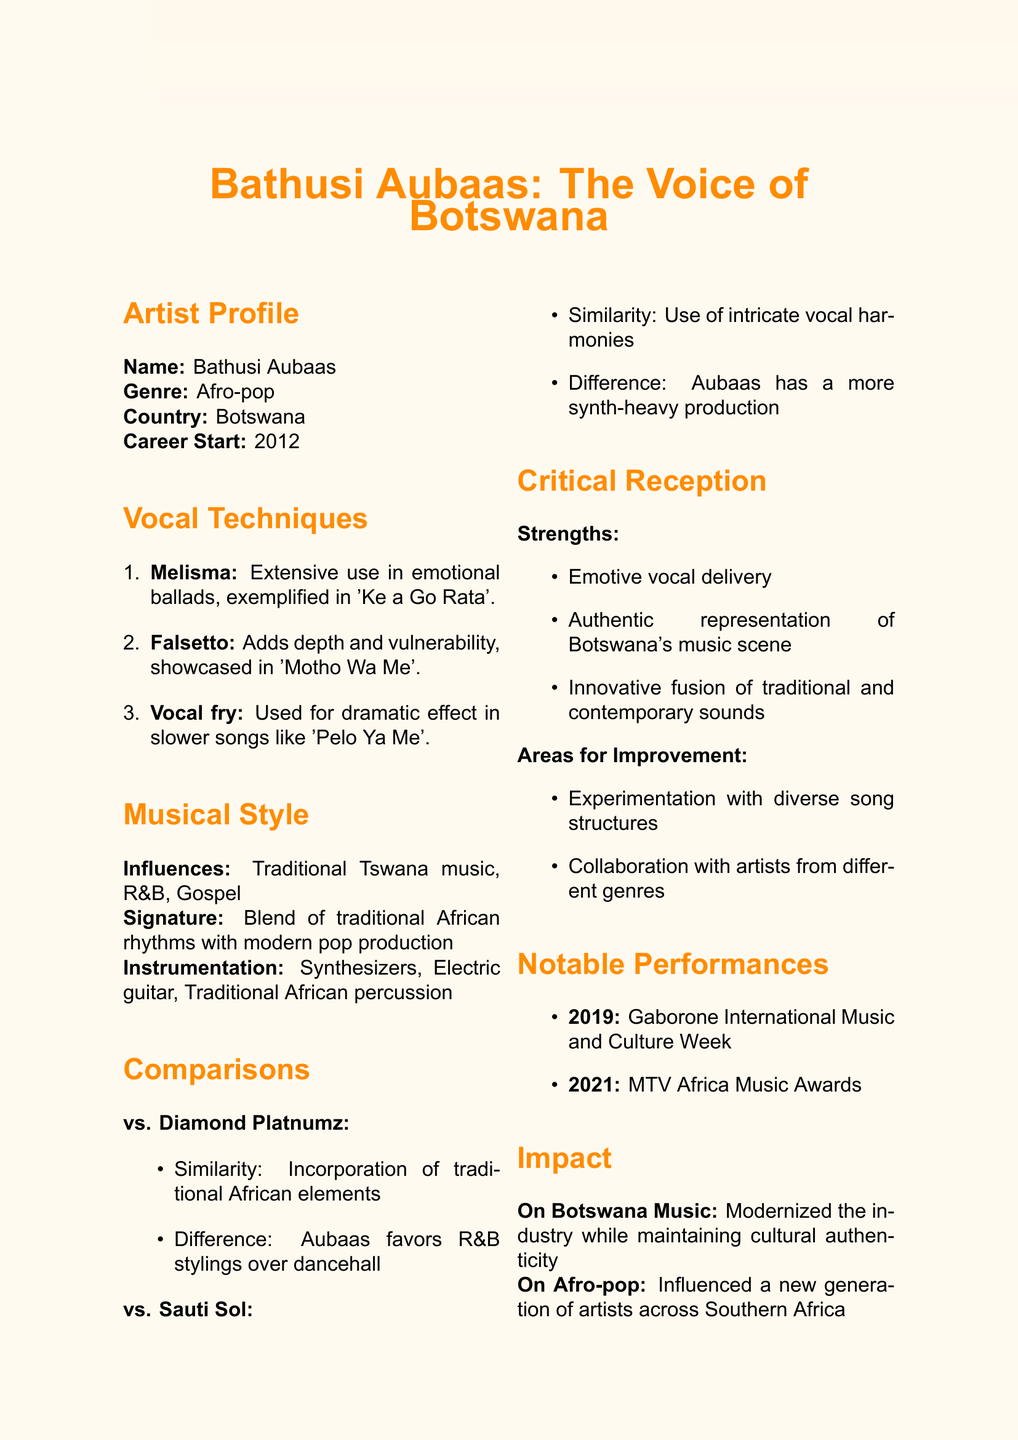What is Bathusi Aubaas's genre? The genre of Bathusi Aubaas is mentioned in the document as Afro-pop.
Answer: Afro-pop In which year did Bathusi Aubaas start his career? The document specifies that his career started in 2012.
Answer: 2012 Which song showcases Bathusi Aubaas's use of melisma? The document provides an example of this technique in his song 'Ke a Go Rata'.
Answer: Ke a Go Rata What is Bathusi Aubaas's most influential song? This information is found under the fan perspective section, which highlights 'Ke a Go Rata'.
Answer: Ke a Go Rata How does Bathusi Aubaas's style compare to Diamond Platnumz? The document states that both artists incorporate traditional African elements, but Aubaas favors R&B stylings.
Answer: Incorporation of traditional African elements What instrument is noted as part of Aubaas’s musical instrumentation? The document lists different instruments including synthesizers.
Answer: Synthesizers What notable performance received a standing ovation? The document mentions that his rendition of 'Tsaya Thebe' at the Gaborone International Music and Culture Week received a standing ovation.
Answer: Tsaya Thebe What area for improvement is suggested for Bathusi Aubaas? The document cites that he could improve by experimenting with more diverse song structures.
Answer: Experimentation with more diverse song structures Which album is a fan favorite? The document states that his favorite album among fans is 'Tsaya Thebe'.
Answer: Tsaya Thebe 